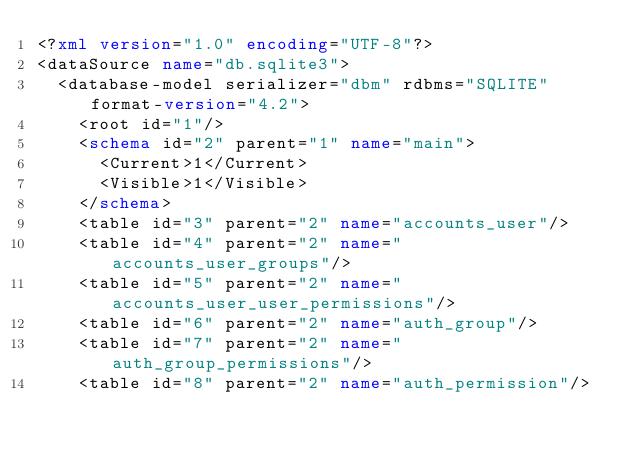Convert code to text. <code><loc_0><loc_0><loc_500><loc_500><_XML_><?xml version="1.0" encoding="UTF-8"?>
<dataSource name="db.sqlite3">
  <database-model serializer="dbm" rdbms="SQLITE" format-version="4.2">
    <root id="1"/>
    <schema id="2" parent="1" name="main">
      <Current>1</Current>
      <Visible>1</Visible>
    </schema>
    <table id="3" parent="2" name="accounts_user"/>
    <table id="4" parent="2" name="accounts_user_groups"/>
    <table id="5" parent="2" name="accounts_user_user_permissions"/>
    <table id="6" parent="2" name="auth_group"/>
    <table id="7" parent="2" name="auth_group_permissions"/>
    <table id="8" parent="2" name="auth_permission"/></code> 